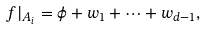Convert formula to latex. <formula><loc_0><loc_0><loc_500><loc_500>f | _ { A _ { i } } = \phi + w _ { 1 } + \dots + w _ { d - 1 } ,</formula> 